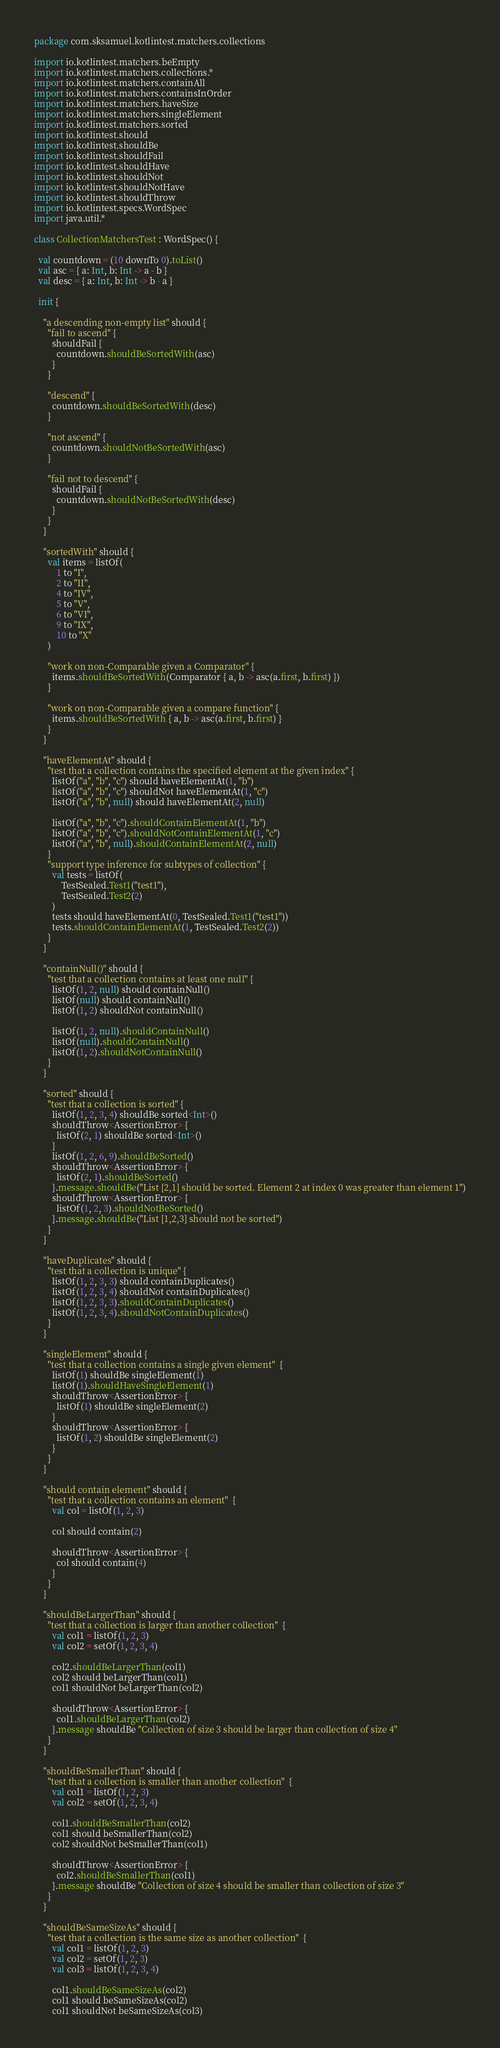Convert code to text. <code><loc_0><loc_0><loc_500><loc_500><_Kotlin_>package com.sksamuel.kotlintest.matchers.collections

import io.kotlintest.matchers.beEmpty
import io.kotlintest.matchers.collections.*
import io.kotlintest.matchers.containAll
import io.kotlintest.matchers.containsInOrder
import io.kotlintest.matchers.haveSize
import io.kotlintest.matchers.singleElement
import io.kotlintest.matchers.sorted
import io.kotlintest.should
import io.kotlintest.shouldBe
import io.kotlintest.shouldFail
import io.kotlintest.shouldHave
import io.kotlintest.shouldNot
import io.kotlintest.shouldNotHave
import io.kotlintest.shouldThrow
import io.kotlintest.specs.WordSpec
import java.util.*

class CollectionMatchersTest : WordSpec() {

  val countdown = (10 downTo 0).toList()
  val asc = { a: Int, b: Int -> a - b }
  val desc = { a: Int, b: Int -> b - a }

  init {

    "a descending non-empty list" should {
      "fail to ascend" {
        shouldFail {
          countdown.shouldBeSortedWith(asc)
        }
      }

      "descend" {
        countdown.shouldBeSortedWith(desc)
      }

      "not ascend" {
        countdown.shouldNotBeSortedWith(asc)
      }

      "fail not to descend" {
        shouldFail {
          countdown.shouldNotBeSortedWith(desc)
        }
      }
    }

    "sortedWith" should {
      val items = listOf(
          1 to "I",
          2 to "II",
          4 to "IV",
          5 to "V",
          6 to "VI",
          9 to "IX",
          10 to "X"
      )

      "work on non-Comparable given a Comparator" {
        items.shouldBeSortedWith(Comparator { a, b -> asc(a.first, b.first) })
      }

      "work on non-Comparable given a compare function" {
        items.shouldBeSortedWith { a, b -> asc(a.first, b.first) }
      }
    }

    "haveElementAt" should {
      "test that a collection contains the specified element at the given index" {
        listOf("a", "b", "c") should haveElementAt(1, "b")
        listOf("a", "b", "c") shouldNot haveElementAt(1, "c")
        listOf("a", "b", null) should haveElementAt(2, null)

        listOf("a", "b", "c").shouldContainElementAt(1, "b")
        listOf("a", "b", "c").shouldNotContainElementAt(1, "c")
        listOf("a", "b", null).shouldContainElementAt(2, null)
      }
      "support type inference for subtypes of collection" {
        val tests = listOf(
            TestSealed.Test1("test1"),
            TestSealed.Test2(2)
        )
        tests should haveElementAt(0, TestSealed.Test1("test1"))
        tests.shouldContainElementAt(1, TestSealed.Test2(2))
      }
    }

    "containNull()" should {
      "test that a collection contains at least one null" {
        listOf(1, 2, null) should containNull()
        listOf(null) should containNull()
        listOf(1, 2) shouldNot containNull()

        listOf(1, 2, null).shouldContainNull()
        listOf(null).shouldContainNull()
        listOf(1, 2).shouldNotContainNull()
      }
    }

    "sorted" should {
      "test that a collection is sorted" {
        listOf(1, 2, 3, 4) shouldBe sorted<Int>()
        shouldThrow<AssertionError> {
          listOf(2, 1) shouldBe sorted<Int>()
        }
        listOf(1, 2, 6, 9).shouldBeSorted()
        shouldThrow<AssertionError> {
          listOf(2, 1).shouldBeSorted()
        }.message.shouldBe("List [2,1] should be sorted. Element 2 at index 0 was greater than element 1")
        shouldThrow<AssertionError> {
          listOf(1, 2, 3).shouldNotBeSorted()
        }.message.shouldBe("List [1,2,3] should not be sorted")
      }
    }

    "haveDuplicates" should {
      "test that a collection is unique" {
        listOf(1, 2, 3, 3) should containDuplicates()
        listOf(1, 2, 3, 4) shouldNot containDuplicates()
        listOf(1, 2, 3, 3).shouldContainDuplicates()
        listOf(1, 2, 3, 4).shouldNotContainDuplicates()
      }
    }

    "singleElement" should {
      "test that a collection contains a single given element"  {
        listOf(1) shouldBe singleElement(1)
        listOf(1).shouldHaveSingleElement(1)
        shouldThrow<AssertionError> {
          listOf(1) shouldBe singleElement(2)
        }
        shouldThrow<AssertionError> {
          listOf(1, 2) shouldBe singleElement(2)
        }
      }
    }

    "should contain element" should {
      "test that a collection contains an element"  {
        val col = listOf(1, 2, 3)

        col should contain(2)

        shouldThrow<AssertionError> {
          col should contain(4)
        }
      }
    }

    "shouldBeLargerThan" should {
      "test that a collection is larger than another collection"  {
        val col1 = listOf(1, 2, 3)
        val col2 = setOf(1, 2, 3, 4)

        col2.shouldBeLargerThan(col1)
        col2 should beLargerThan(col1)
        col1 shouldNot beLargerThan(col2)

        shouldThrow<AssertionError> {
          col1.shouldBeLargerThan(col2)
        }.message shouldBe "Collection of size 3 should be larger than collection of size 4"
      }
    }

    "shouldBeSmallerThan" should {
      "test that a collection is smaller than another collection"  {
        val col1 = listOf(1, 2, 3)
        val col2 = setOf(1, 2, 3, 4)

        col1.shouldBeSmallerThan(col2)
        col1 should beSmallerThan(col2)
        col2 shouldNot beSmallerThan(col1)

        shouldThrow<AssertionError> {
          col2.shouldBeSmallerThan(col1)
        }.message shouldBe "Collection of size 4 should be smaller than collection of size 3"
      }
    }

    "shouldBeSameSizeAs" should {
      "test that a collection is the same size as another collection"  {
        val col1 = listOf(1, 2, 3)
        val col2 = setOf(1, 2, 3)
        val col3 = listOf(1, 2, 3, 4)

        col1.shouldBeSameSizeAs(col2)
        col1 should beSameSizeAs(col2)
        col1 shouldNot beSameSizeAs(col3)
</code> 